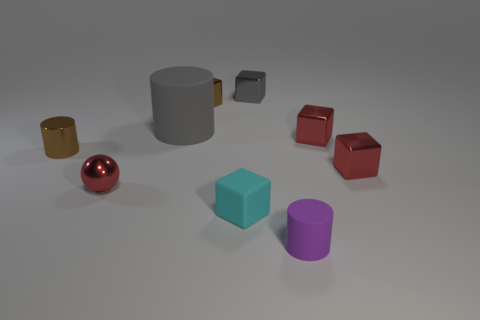Add 1 small yellow shiny objects. How many objects exist? 10 Subtract all blocks. How many objects are left? 4 Add 5 cubes. How many cubes exist? 10 Subtract 1 cyan cubes. How many objects are left? 8 Subtract all green cylinders. Subtract all matte objects. How many objects are left? 6 Add 2 gray blocks. How many gray blocks are left? 3 